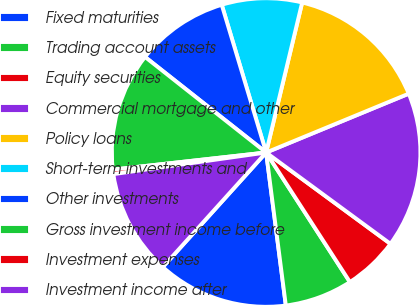Convert chart. <chart><loc_0><loc_0><loc_500><loc_500><pie_chart><fcel>Fixed maturities<fcel>Trading account assets<fcel>Equity securities<fcel>Commercial mortgage and other<fcel>Policy loans<fcel>Short-term investments and<fcel>Other investments<fcel>Gross investment income before<fcel>Investment expenses<fcel>Investment income after<nl><fcel>13.72%<fcel>7.1%<fcel>5.78%<fcel>16.31%<fcel>15.02%<fcel>8.4%<fcel>9.72%<fcel>12.4%<fcel>0.47%<fcel>11.08%<nl></chart> 